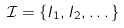Convert formula to latex. <formula><loc_0><loc_0><loc_500><loc_500>\mathcal { I } = \{ I _ { 1 } , I _ { 2 } , \dots \}</formula> 